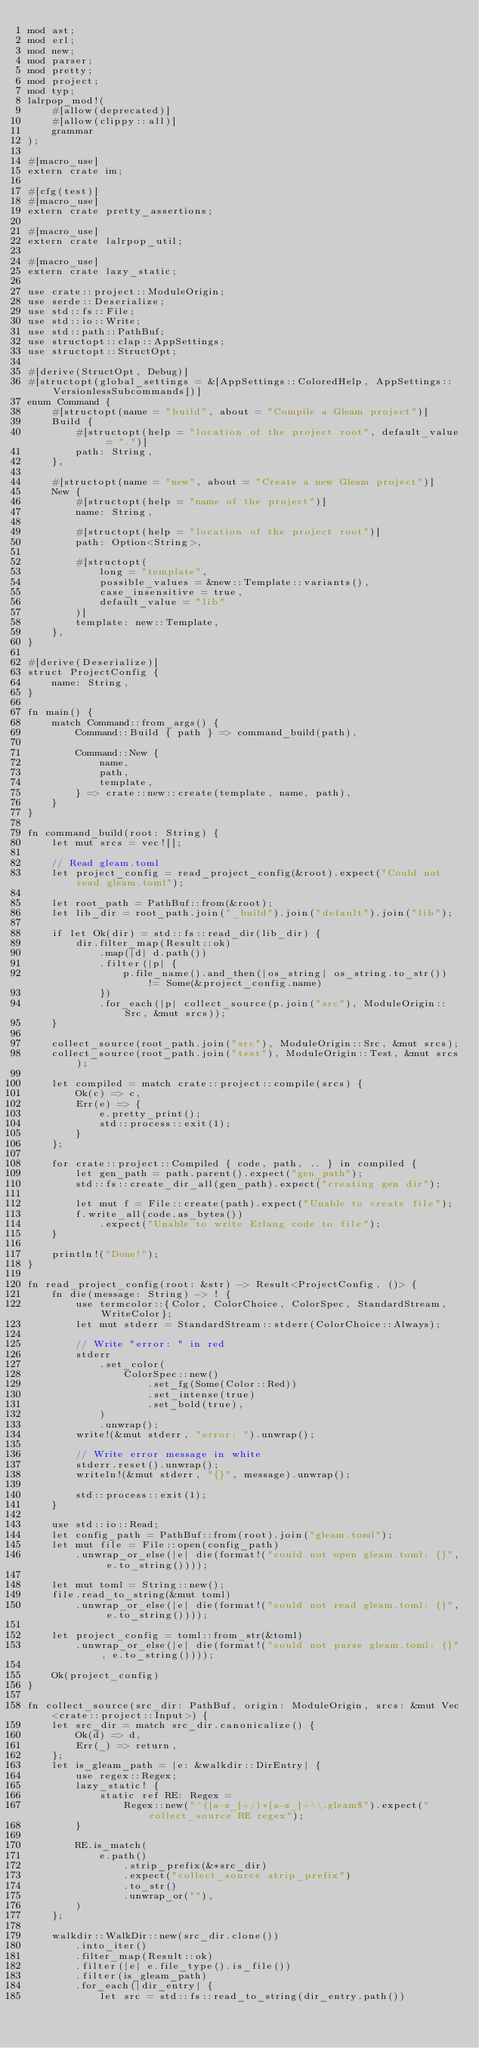<code> <loc_0><loc_0><loc_500><loc_500><_Rust_>mod ast;
mod erl;
mod new;
mod parser;
mod pretty;
mod project;
mod typ;
lalrpop_mod!(
    #[allow(deprecated)]
    #[allow(clippy::all)]
    grammar
);

#[macro_use]
extern crate im;

#[cfg(test)]
#[macro_use]
extern crate pretty_assertions;

#[macro_use]
extern crate lalrpop_util;

#[macro_use]
extern crate lazy_static;

use crate::project::ModuleOrigin;
use serde::Deserialize;
use std::fs::File;
use std::io::Write;
use std::path::PathBuf;
use structopt::clap::AppSettings;
use structopt::StructOpt;

#[derive(StructOpt, Debug)]
#[structopt(global_settings = &[AppSettings::ColoredHelp, AppSettings::VersionlessSubcommands])]
enum Command {
    #[structopt(name = "build", about = "Compile a Gleam project")]
    Build {
        #[structopt(help = "location of the project root", default_value = ".")]
        path: String,
    },

    #[structopt(name = "new", about = "Create a new Gleam project")]
    New {
        #[structopt(help = "name of the project")]
        name: String,

        #[structopt(help = "location of the project root")]
        path: Option<String>,

        #[structopt(
            long = "template",
            possible_values = &new::Template::variants(),
            case_insensitive = true,
            default_value = "lib"
        )]
        template: new::Template,
    },
}

#[derive(Deserialize)]
struct ProjectConfig {
    name: String,
}

fn main() {
    match Command::from_args() {
        Command::Build { path } => command_build(path),

        Command::New {
            name,
            path,
            template,
        } => crate::new::create(template, name, path),
    }
}

fn command_build(root: String) {
    let mut srcs = vec![];

    // Read gleam.toml
    let project_config = read_project_config(&root).expect("Could not read gleam.toml");

    let root_path = PathBuf::from(&root);
    let lib_dir = root_path.join("_build").join("default").join("lib");

    if let Ok(dir) = std::fs::read_dir(lib_dir) {
        dir.filter_map(Result::ok)
            .map(|d| d.path())
            .filter(|p| {
                p.file_name().and_then(|os_string| os_string.to_str()) != Some(&project_config.name)
            })
            .for_each(|p| collect_source(p.join("src"), ModuleOrigin::Src, &mut srcs));
    }

    collect_source(root_path.join("src"), ModuleOrigin::Src, &mut srcs);
    collect_source(root_path.join("test"), ModuleOrigin::Test, &mut srcs);

    let compiled = match crate::project::compile(srcs) {
        Ok(c) => c,
        Err(e) => {
            e.pretty_print();
            std::process::exit(1);
        }
    };

    for crate::project::Compiled { code, path, .. } in compiled {
        let gen_path = path.parent().expect("gen_path");
        std::fs::create_dir_all(gen_path).expect("creating gen dir");

        let mut f = File::create(path).expect("Unable to create file");
        f.write_all(code.as_bytes())
            .expect("Unable to write Erlang code to file");
    }

    println!("Done!");
}

fn read_project_config(root: &str) -> Result<ProjectConfig, ()> {
    fn die(message: String) -> ! {
        use termcolor::{Color, ColorChoice, ColorSpec, StandardStream, WriteColor};
        let mut stderr = StandardStream::stderr(ColorChoice::Always);

        // Write "error: " in red
        stderr
            .set_color(
                ColorSpec::new()
                    .set_fg(Some(Color::Red))
                    .set_intense(true)
                    .set_bold(true),
            )
            .unwrap();
        write!(&mut stderr, "error: ").unwrap();

        // Write error message in white
        stderr.reset().unwrap();
        writeln!(&mut stderr, "{}", message).unwrap();

        std::process::exit(1);
    }

    use std::io::Read;
    let config_path = PathBuf::from(root).join("gleam.toml");
    let mut file = File::open(config_path)
        .unwrap_or_else(|e| die(format!("could not open gleam.toml: {}", e.to_string())));

    let mut toml = String::new();
    file.read_to_string(&mut toml)
        .unwrap_or_else(|e| die(format!("could not read gleam.toml: {}", e.to_string())));

    let project_config = toml::from_str(&toml)
        .unwrap_or_else(|e| die(format!("could not parse gleam.toml: {}", e.to_string())));

    Ok(project_config)
}

fn collect_source(src_dir: PathBuf, origin: ModuleOrigin, srcs: &mut Vec<crate::project::Input>) {
    let src_dir = match src_dir.canonicalize() {
        Ok(d) => d,
        Err(_) => return,
    };
    let is_gleam_path = |e: &walkdir::DirEntry| {
        use regex::Regex;
        lazy_static! {
            static ref RE: Regex =
                Regex::new("^([a-z_]+/)*[a-z_]+\\.gleam$").expect("collect_source RE regex");
        }

        RE.is_match(
            e.path()
                .strip_prefix(&*src_dir)
                .expect("collect_source strip_prefix")
                .to_str()
                .unwrap_or(""),
        )
    };

    walkdir::WalkDir::new(src_dir.clone())
        .into_iter()
        .filter_map(Result::ok)
        .filter(|e| e.file_type().is_file())
        .filter(is_gleam_path)
        .for_each(|dir_entry| {
            let src = std::fs::read_to_string(dir_entry.path())</code> 